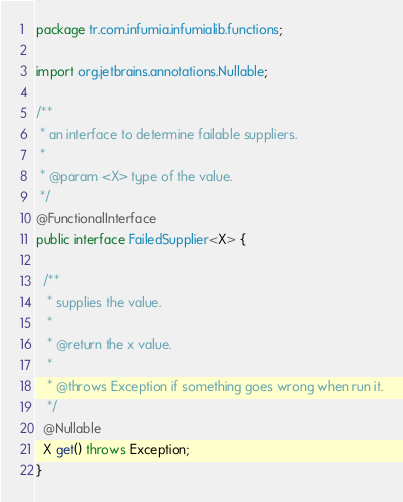<code> <loc_0><loc_0><loc_500><loc_500><_Java_>package tr.com.infumia.infumialib.functions;

import org.jetbrains.annotations.Nullable;

/**
 * an interface to determine failable suppliers.
 *
 * @param <X> type of the value.
 */
@FunctionalInterface
public interface FailedSupplier<X> {

  /**
   * supplies the value.
   *
   * @return the x value.
   *
   * @throws Exception if something goes wrong when run it.
   */
  @Nullable
  X get() throws Exception;
}
</code> 